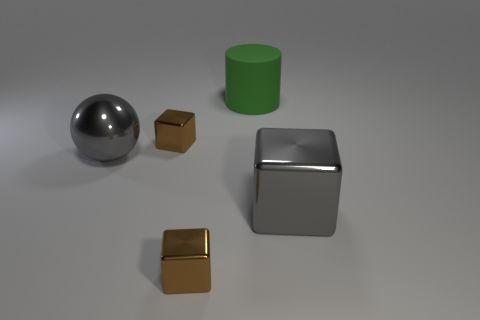Subtract all brown metal cubes. How many cubes are left? 1 Subtract all gray blocks. How many blocks are left? 2 Add 3 brown shiny cylinders. How many objects exist? 8 Subtract all brown cylinders. How many brown cubes are left? 2 Subtract 1 balls. How many balls are left? 0 Subtract all blocks. How many objects are left? 2 Add 1 brown metal cubes. How many brown metal cubes are left? 3 Add 3 balls. How many balls exist? 4 Subtract 1 gray blocks. How many objects are left? 4 Subtract all purple cubes. Subtract all brown cylinders. How many cubes are left? 3 